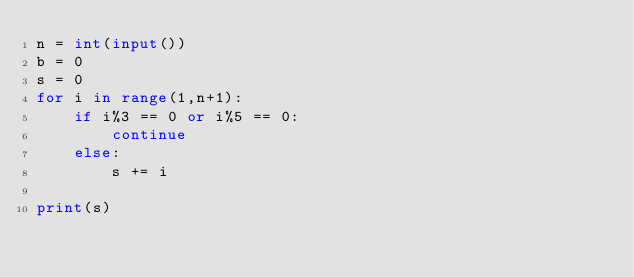Convert code to text. <code><loc_0><loc_0><loc_500><loc_500><_Python_>n = int(input())
b = 0
s = 0
for i in range(1,n+1):
    if i%3 == 0 or i%5 == 0:
        continue
    else:
        s += i
        
print(s)</code> 